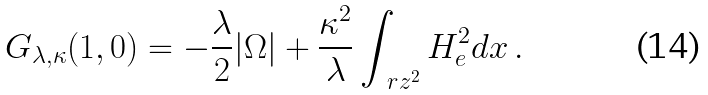<formula> <loc_0><loc_0><loc_500><loc_500>G _ { \lambda , \kappa } ( 1 , 0 ) = - \frac { \lambda } { 2 } | \Omega | + \frac { \kappa ^ { 2 } } { \lambda } \int _ { \ r z ^ { 2 } } H _ { e } ^ { 2 } d x \, .</formula> 